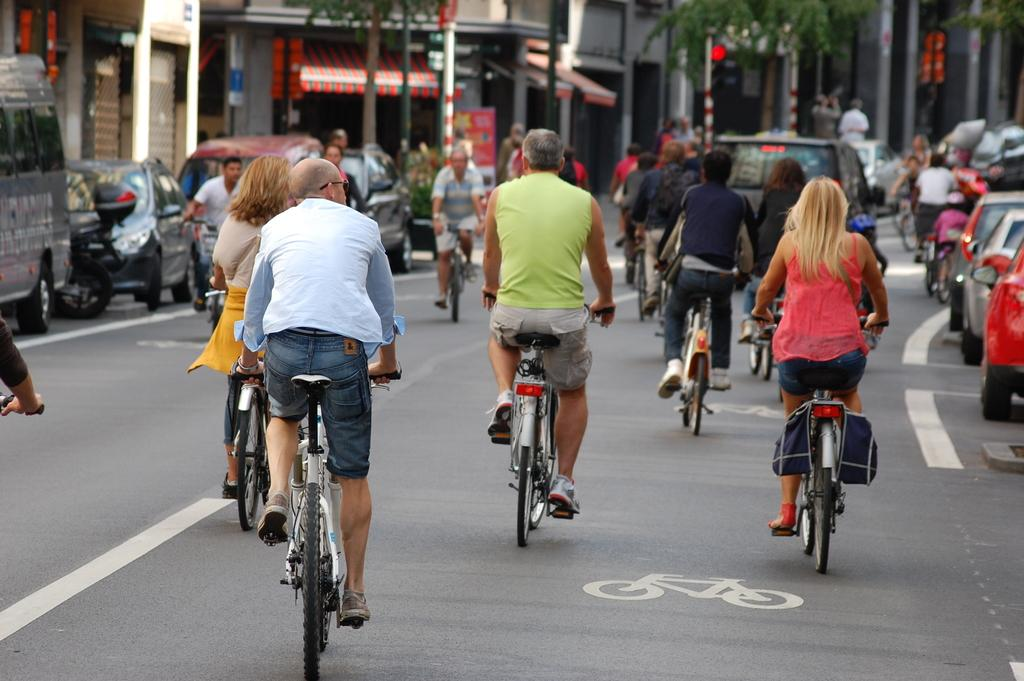What are the people in the image doing? The people in the image are cycling on the roads. What vehicles can be seen in the image? There are cars on the right corner and left corner of the image. What can be seen in the background of the image? There are stores, a tent, trees, and buildings in the background of the image. What is the belief of the people in the image? There is no mention of beliefs in the image. --- Facts: 1. There is a person in the image. 2. The person is wearing a hat. 3. The person is holding a book. 4. The person is standing in front of a bookshelf. 5. The bookshelf has books on it. Absurd Topics: elephant, piano Conversation: Who or what is in the image? There is a person in the image. What is the person wearing? The person is wearing a hat. What is the person holding? The person is holding a book. What is behind the person? The person is standing in front of a bookshelf. What can be seen on the bookshelf? The bookshelf has books on it. Reasoning: Let's think step by step in order to produce the conversation. We start by identifying the main subject of the image, which is the person. Next, we describe the person's attire, which is a hat. Then, we observe the action of the person, noting that they are holding a book. Finally, we describe the background setting, which is a bookshelf with books on it. Absurd Question/Answer: What type of elephant can be seen playing the piano in the image? There is no elephant, piano, or any musical instrument present in the image. 